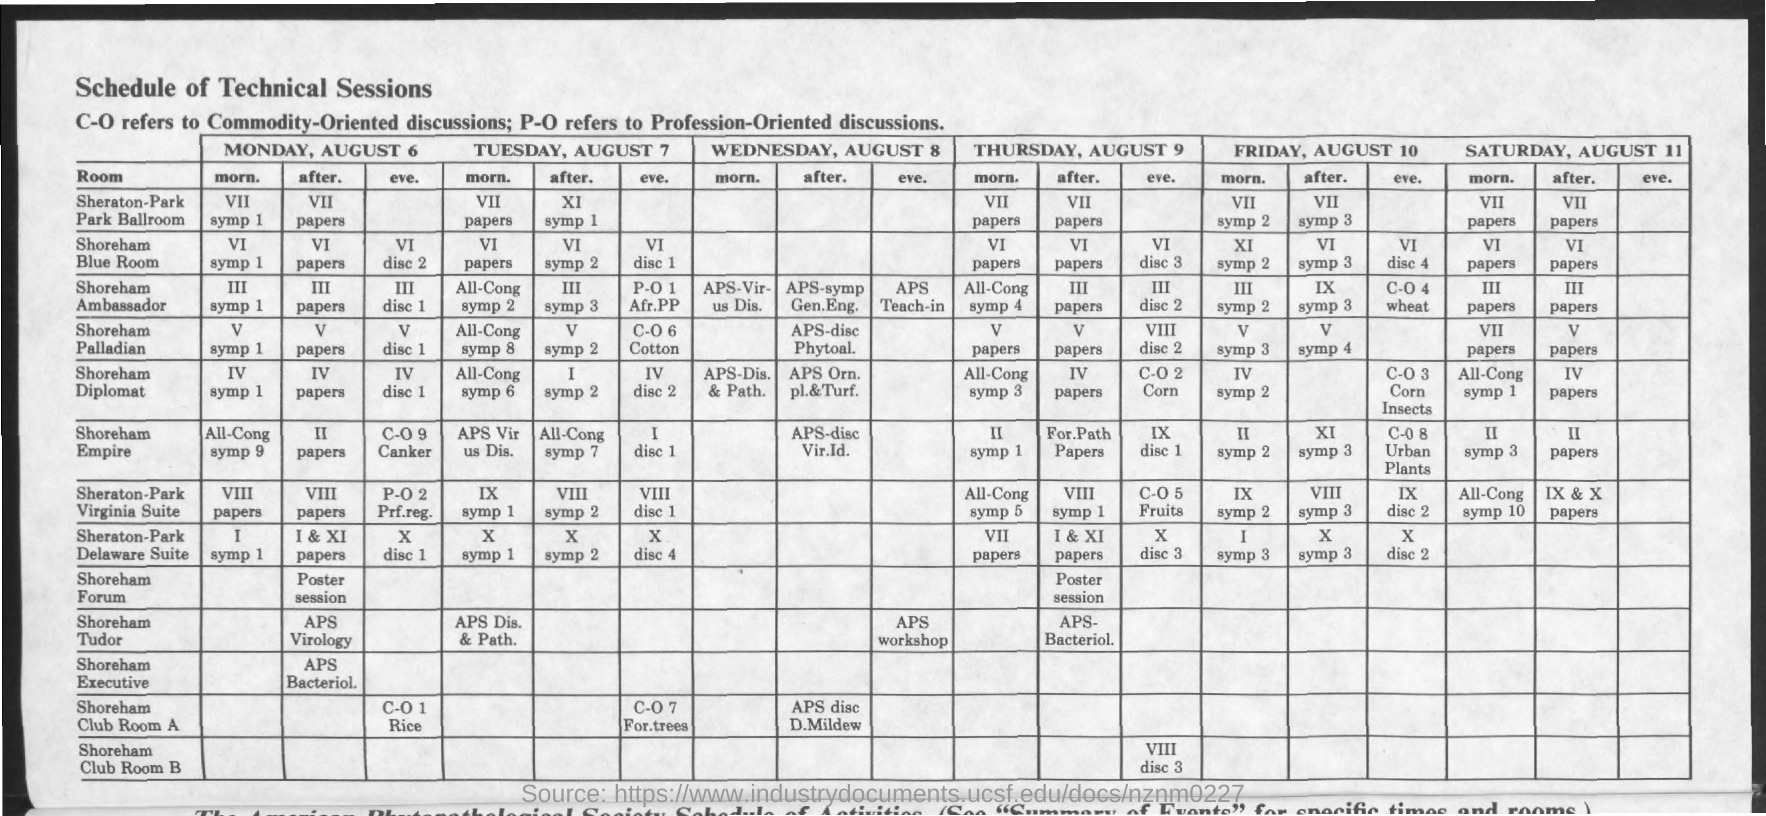Draw attention to some important aspects in this diagram. Commodity-oriented is a term used to describe something that is focused on or concerned with commodities. The document in question is titled 'Schedule of Technical Sessions.' The abbreviation P-O stands for profession-oriented, which refers to an individual's career focus and dedication to a specific profession. 